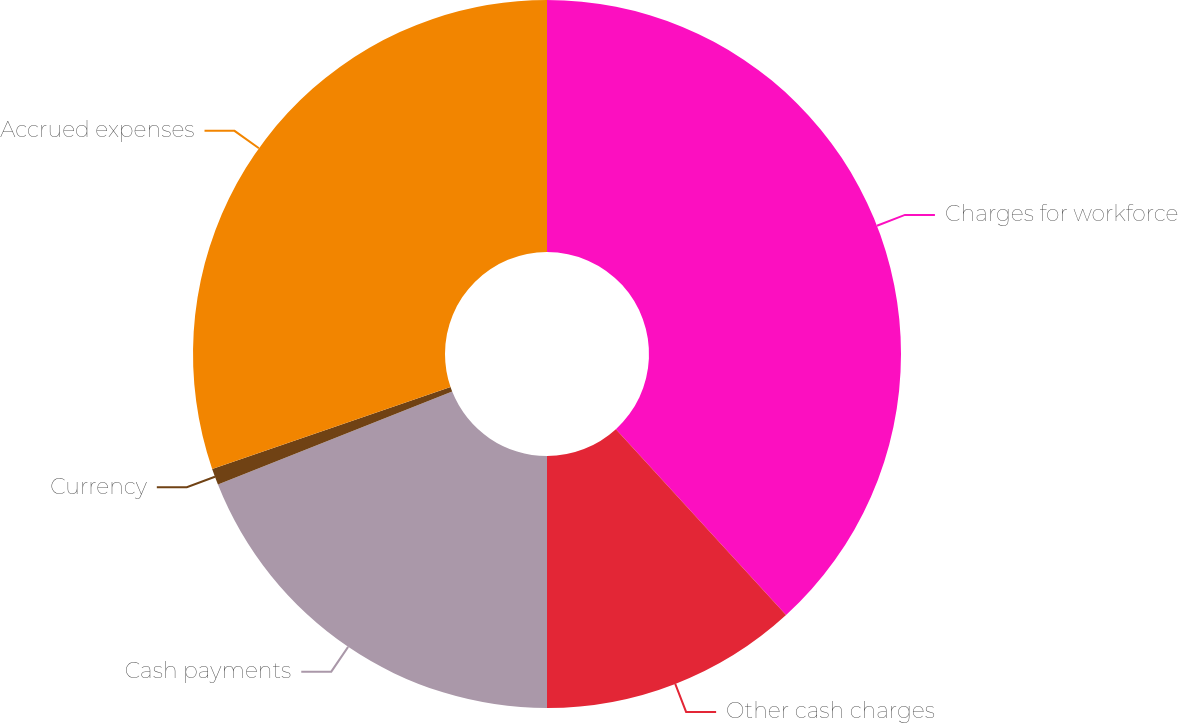Convert chart to OTSL. <chart><loc_0><loc_0><loc_500><loc_500><pie_chart><fcel>Charges for workforce<fcel>Other cash charges<fcel>Cash payments<fcel>Currency<fcel>Accrued expenses<nl><fcel>38.2%<fcel>11.8%<fcel>18.99%<fcel>0.75%<fcel>30.26%<nl></chart> 